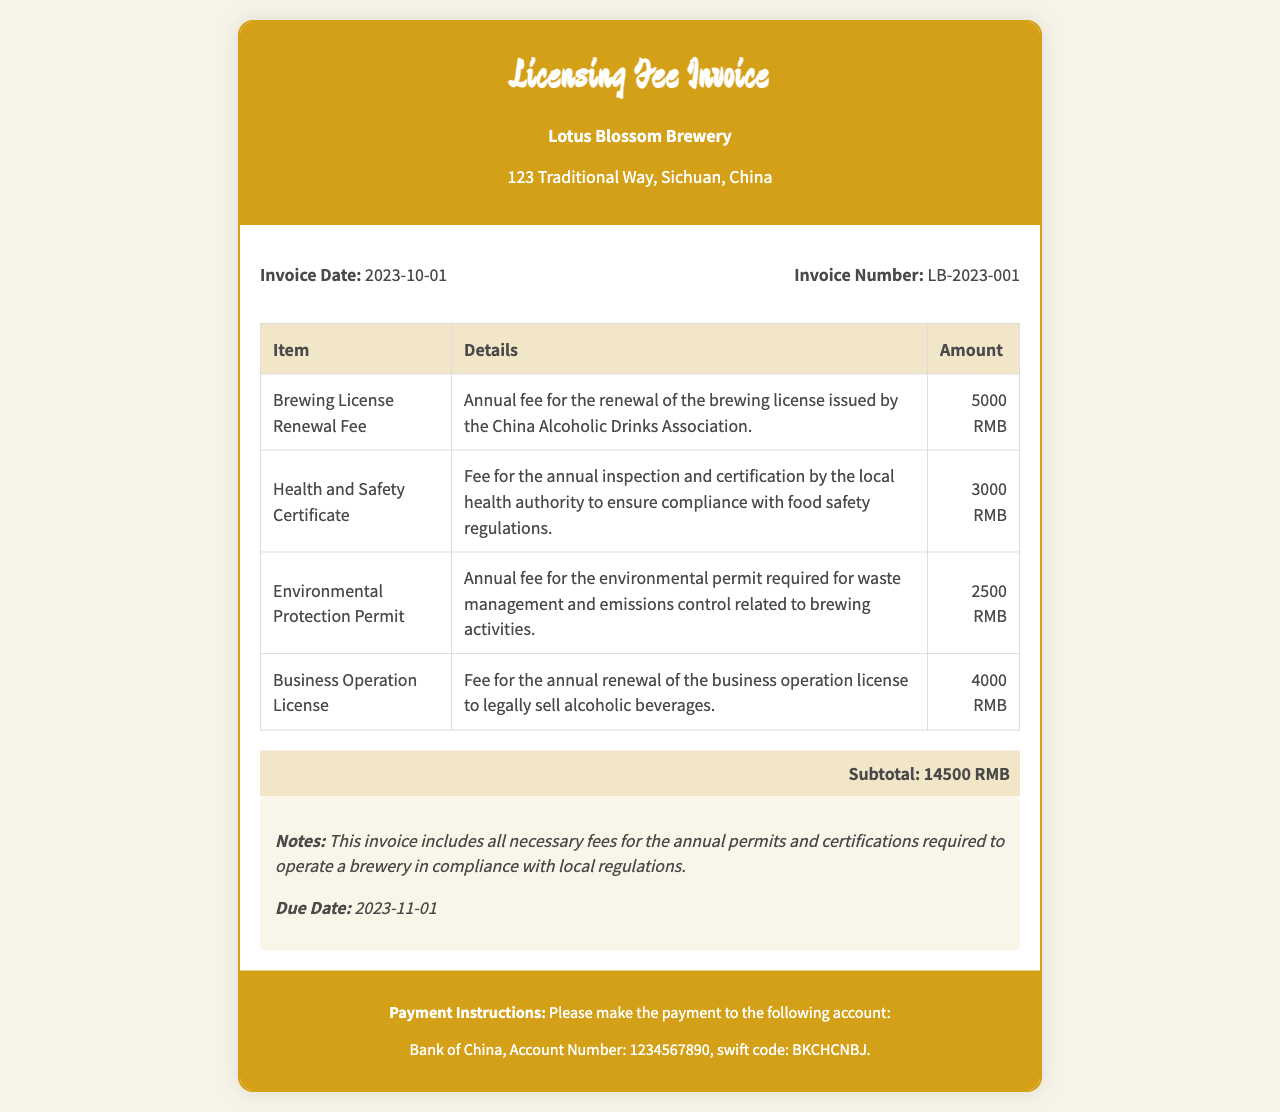what is the invoice date? The invoice date is specified in the document clearly.
Answer: 2023-10-01 what is the invoice number? The invoice number is indicated in the document.
Answer: LB-2023-001 how much is the Brewing License Renewal Fee? The Brewing License Renewal Fee is listed in the itemized section.
Answer: 5000 RMB what is the total amount of the invoice? The total amount is presented as the subtotal at the end of the invoice.
Answer: 14500 RMB when is the due date for this invoice? The due date is provided within the notes section of the document.
Answer: 2023-11-01 which authority issues the Brewing License? The authority that issues the Brewing License is mentioned in the details of the fee.
Answer: China Alcoholic Drinks Association what is included in the environmental permit fee? The environmental permit fee details the purpose required for brewing activities.
Answer: waste management and emissions control what type of license does this invoice cover? This invoice specifically covers the licensing fees for a certain type of operation.
Answer: business operation license what are the payment instructions? The payment instructions are included in the footer of the invoice.
Answer: Bank of China, Account Number: 1234567890, swift code: BKCHCNBJ 